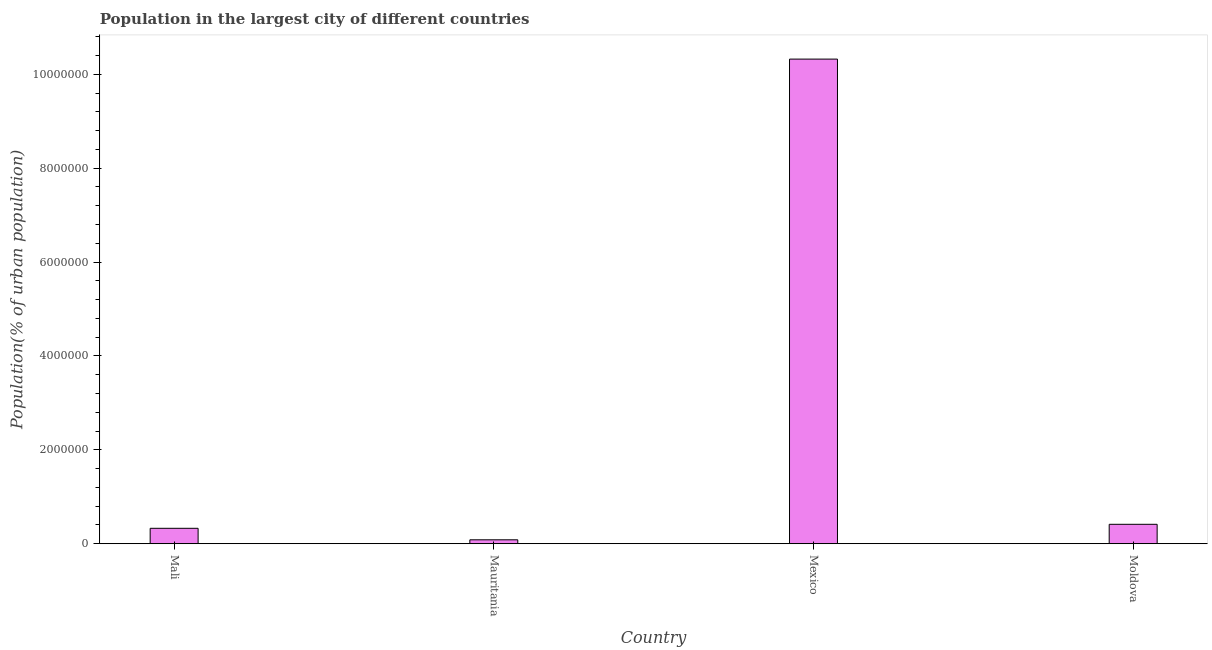What is the title of the graph?
Ensure brevity in your answer.  Population in the largest city of different countries. What is the label or title of the Y-axis?
Provide a short and direct response. Population(% of urban population). What is the population in largest city in Mauritania?
Offer a terse response. 8.40e+04. Across all countries, what is the maximum population in largest city?
Ensure brevity in your answer.  1.03e+07. Across all countries, what is the minimum population in largest city?
Keep it short and to the point. 8.40e+04. In which country was the population in largest city maximum?
Keep it short and to the point. Mexico. In which country was the population in largest city minimum?
Your response must be concise. Mauritania. What is the sum of the population in largest city?
Provide a short and direct response. 1.12e+07. What is the difference between the population in largest city in Mexico and Moldova?
Provide a succinct answer. 9.91e+06. What is the average population in largest city per country?
Make the answer very short. 2.79e+06. What is the median population in largest city?
Your answer should be compact. 3.72e+05. What is the ratio of the population in largest city in Mali to that in Mauritania?
Provide a short and direct response. 3.92. Is the difference between the population in largest city in Mali and Moldova greater than the difference between any two countries?
Make the answer very short. No. What is the difference between the highest and the second highest population in largest city?
Provide a succinct answer. 9.91e+06. What is the difference between the highest and the lowest population in largest city?
Give a very brief answer. 1.02e+07. In how many countries, is the population in largest city greater than the average population in largest city taken over all countries?
Ensure brevity in your answer.  1. Are all the bars in the graph horizontal?
Ensure brevity in your answer.  No. How many countries are there in the graph?
Provide a short and direct response. 4. What is the difference between two consecutive major ticks on the Y-axis?
Your answer should be very brief. 2.00e+06. What is the Population(% of urban population) of Mali?
Your answer should be very brief. 3.29e+05. What is the Population(% of urban population) of Mauritania?
Make the answer very short. 8.40e+04. What is the Population(% of urban population) in Mexico?
Provide a succinct answer. 1.03e+07. What is the Population(% of urban population) in Moldova?
Your answer should be compact. 4.14e+05. What is the difference between the Population(% of urban population) in Mali and Mauritania?
Your answer should be compact. 2.45e+05. What is the difference between the Population(% of urban population) in Mali and Mexico?
Offer a very short reply. -9.99e+06. What is the difference between the Population(% of urban population) in Mali and Moldova?
Offer a terse response. -8.52e+04. What is the difference between the Population(% of urban population) in Mauritania and Mexico?
Provide a short and direct response. -1.02e+07. What is the difference between the Population(% of urban population) in Mauritania and Moldova?
Make the answer very short. -3.30e+05. What is the difference between the Population(% of urban population) in Mexico and Moldova?
Provide a short and direct response. 9.91e+06. What is the ratio of the Population(% of urban population) in Mali to that in Mauritania?
Give a very brief answer. 3.92. What is the ratio of the Population(% of urban population) in Mali to that in Mexico?
Make the answer very short. 0.03. What is the ratio of the Population(% of urban population) in Mali to that in Moldova?
Your answer should be compact. 0.79. What is the ratio of the Population(% of urban population) in Mauritania to that in Mexico?
Keep it short and to the point. 0.01. What is the ratio of the Population(% of urban population) in Mauritania to that in Moldova?
Offer a terse response. 0.2. What is the ratio of the Population(% of urban population) in Mexico to that in Moldova?
Offer a terse response. 24.93. 